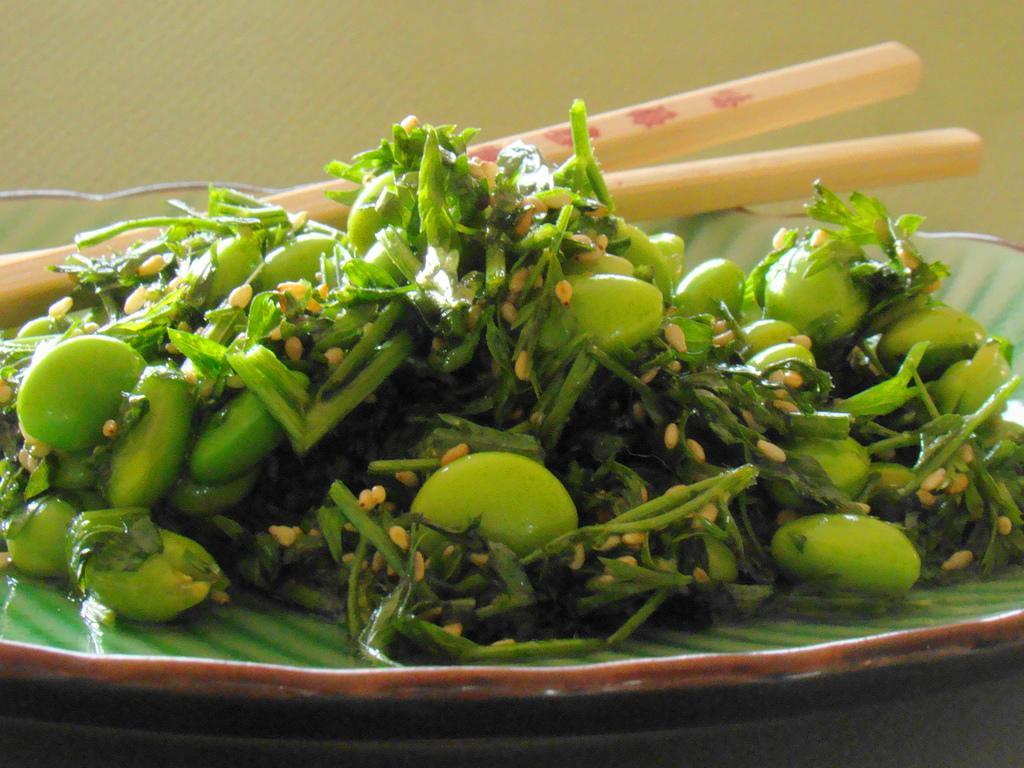Please provide a concise description of this image. In this image there is a plate having few leafy vegetables, chopsticks and some food on it. Plate is kept on a table. 